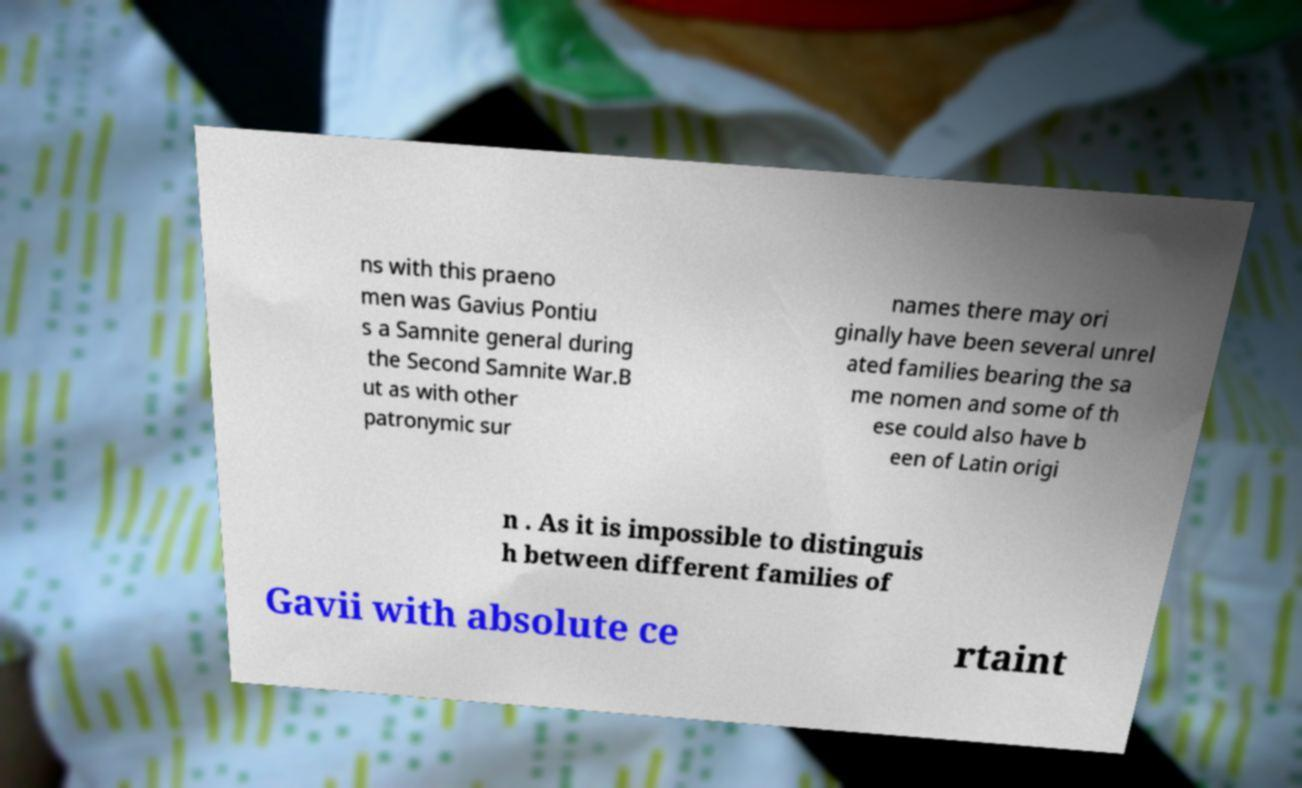Could you extract and type out the text from this image? ns with this praeno men was Gavius Pontiu s a Samnite general during the Second Samnite War.B ut as with other patronymic sur names there may ori ginally have been several unrel ated families bearing the sa me nomen and some of th ese could also have b een of Latin origi n . As it is impossible to distinguis h between different families of Gavii with absolute ce rtaint 